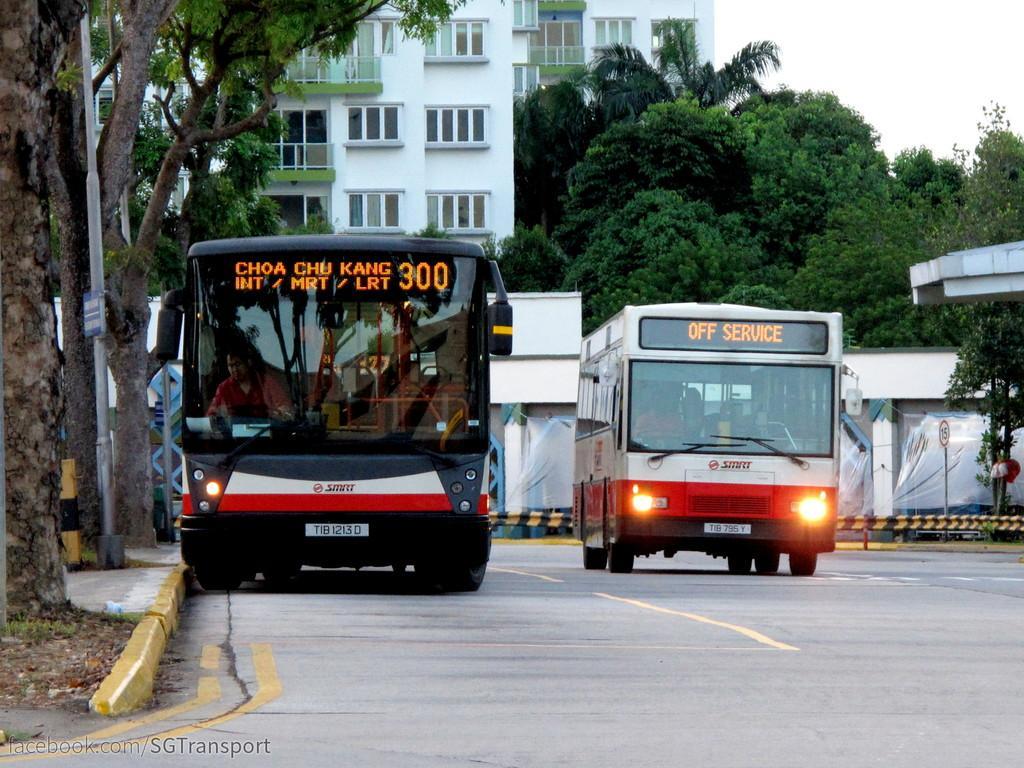Could you give a brief overview of what you see in this image? Here we can see few people are in the two vehicles and riding on the road. In the background there are buildings,windows,poles,trees,sign board poles and sky. 